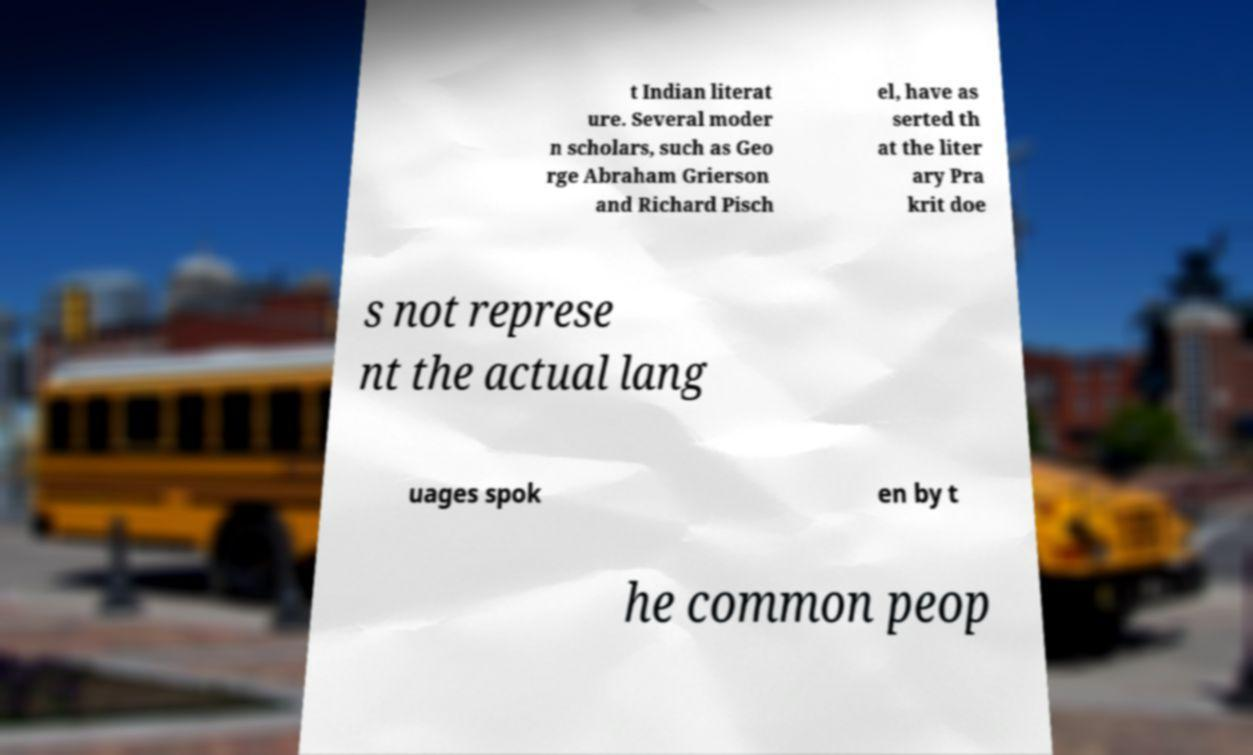There's text embedded in this image that I need extracted. Can you transcribe it verbatim? t Indian literat ure. Several moder n scholars, such as Geo rge Abraham Grierson and Richard Pisch el, have as serted th at the liter ary Pra krit doe s not represe nt the actual lang uages spok en by t he common peop 